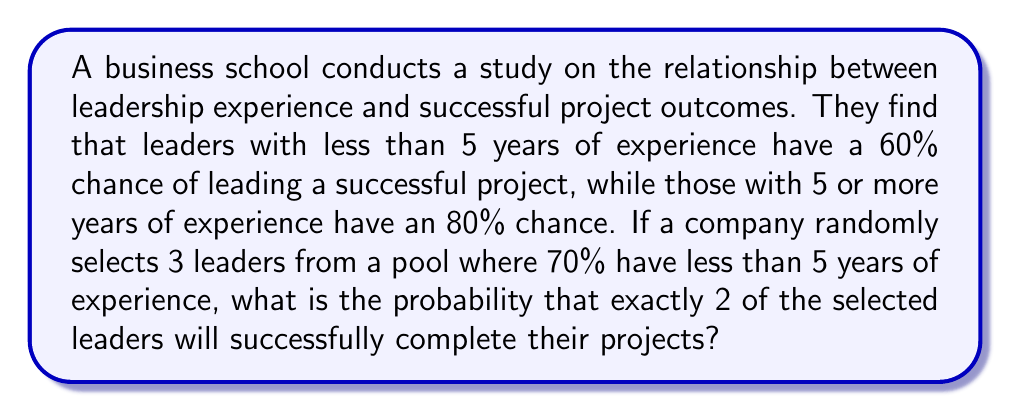Teach me how to tackle this problem. Let's approach this step-by-step:

1) First, we need to calculate the overall probability of a randomly selected leader succeeding:
   
   $P(\text{success}) = 0.7 \cdot 0.6 + 0.3 \cdot 0.8 = 0.42 + 0.24 = 0.66$

2) Now, we have a binomial probability problem. We want exactly 2 successes out of 3 trials, where each trial has a 0.66 probability of success.

3) The probability mass function for a binomial distribution is:

   $$P(X = k) = \binom{n}{k} p^k (1-p)^{n-k}$$

   Where:
   $n$ = number of trials (3)
   $k$ = number of successes (2)
   $p$ = probability of success on each trial (0.66)

4) Plugging in our values:

   $$P(X = 2) = \binom{3}{2} (0.66)^2 (1-0.66)^{3-2}$$

5) Simplify:
   
   $$P(X = 2) = 3 \cdot (0.66)^2 \cdot (0.34)^1$$

6) Calculate:
   
   $$P(X = 2) = 3 \cdot 0.4356 \cdot 0.34 = 0.4444$$

7) Round to four decimal places:

   $$P(X = 2) \approx 0.4444$$
Answer: 0.4444 